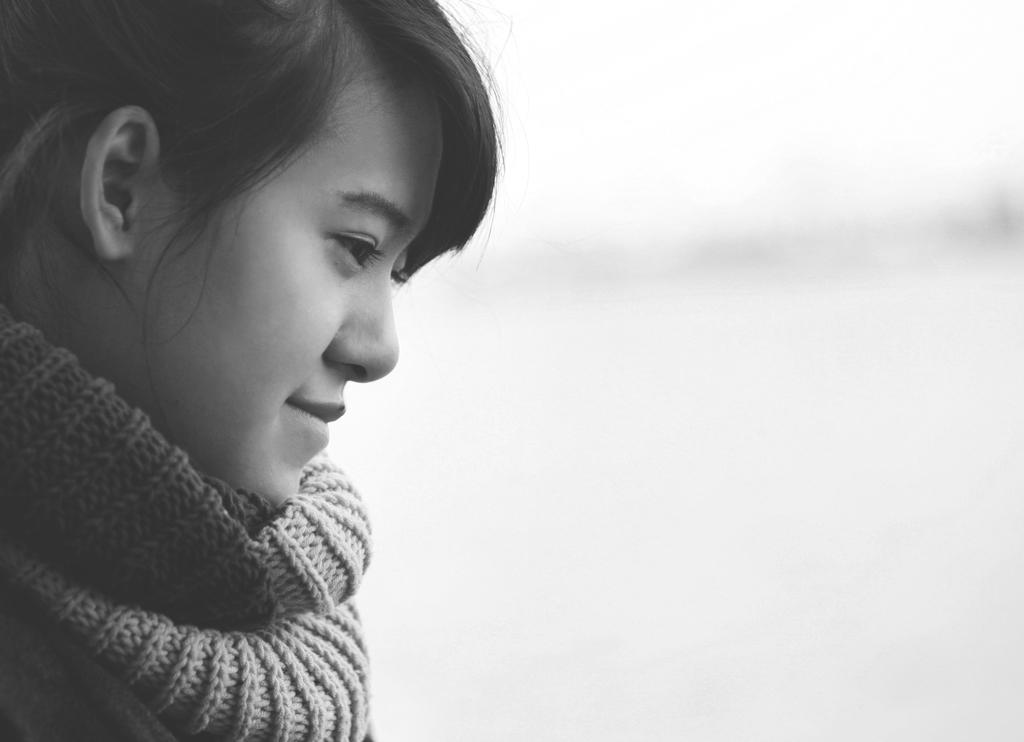Who is the main subject in the image? There is a girl in the image. What is the girl's expression in the image? The girl is smiling in the image. What type of clothing is the girl wearing? The girl is wearing woolen cloth in the image. What time does the clock show in the image? There is no clock present in the image. 